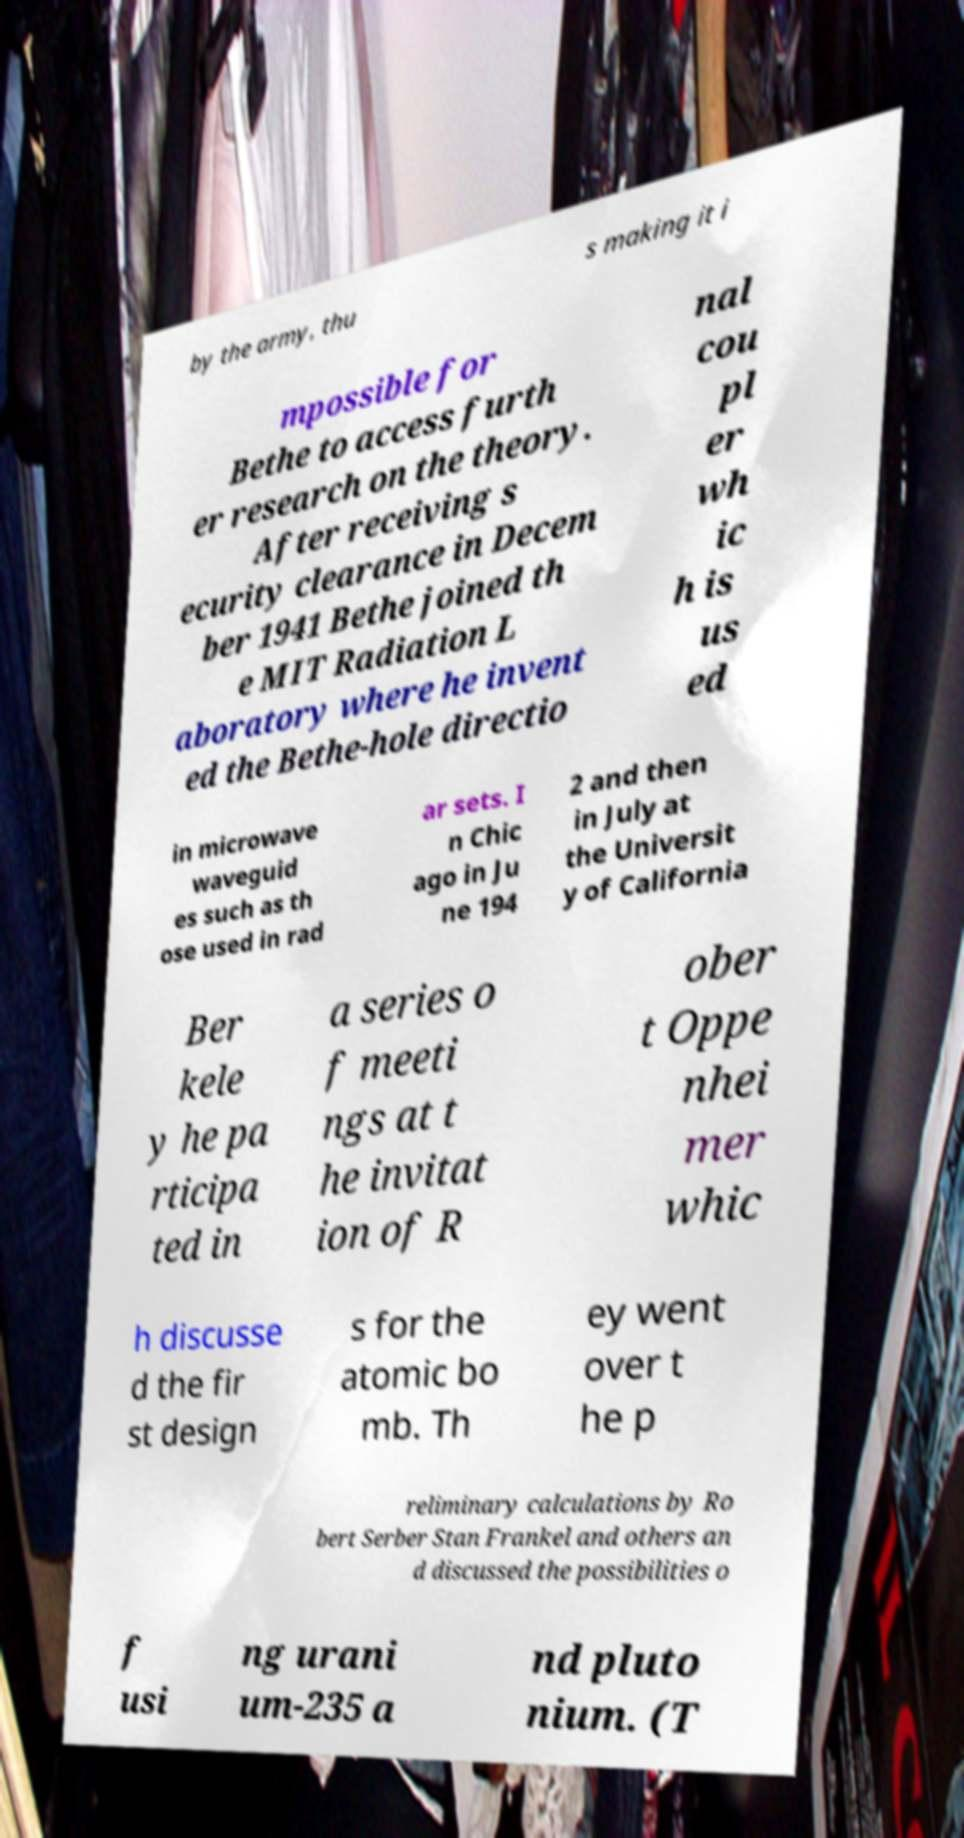Can you read and provide the text displayed in the image?This photo seems to have some interesting text. Can you extract and type it out for me? by the army, thu s making it i mpossible for Bethe to access furth er research on the theory. After receiving s ecurity clearance in Decem ber 1941 Bethe joined th e MIT Radiation L aboratory where he invent ed the Bethe-hole directio nal cou pl er wh ic h is us ed in microwave waveguid es such as th ose used in rad ar sets. I n Chic ago in Ju ne 194 2 and then in July at the Universit y of California Ber kele y he pa rticipa ted in a series o f meeti ngs at t he invitat ion of R ober t Oppe nhei mer whic h discusse d the fir st design s for the atomic bo mb. Th ey went over t he p reliminary calculations by Ro bert Serber Stan Frankel and others an d discussed the possibilities o f usi ng urani um-235 a nd pluto nium. (T 